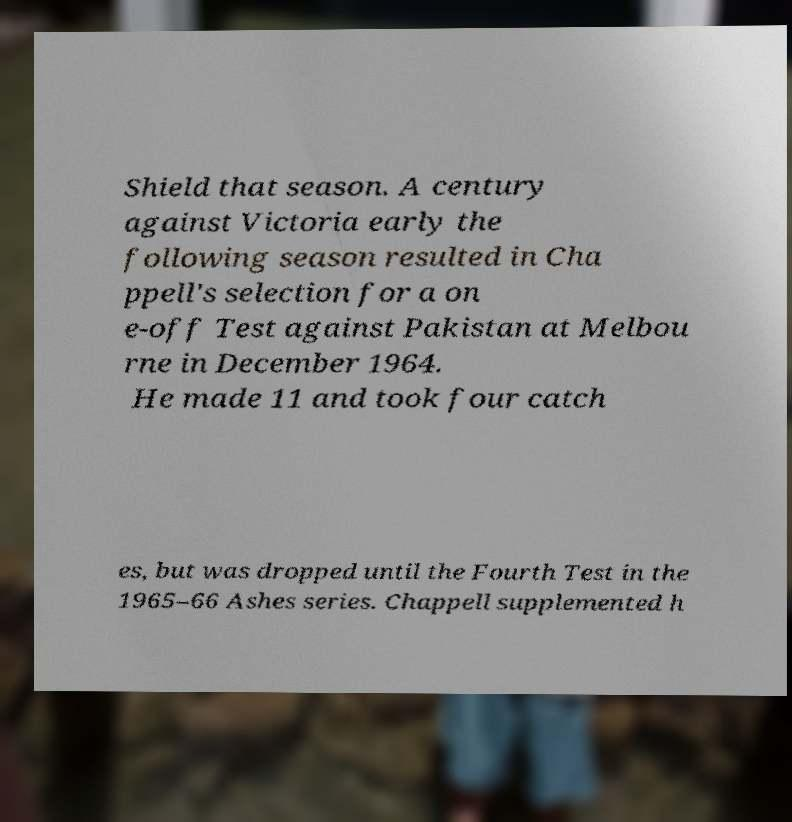Can you accurately transcribe the text from the provided image for me? Shield that season. A century against Victoria early the following season resulted in Cha ppell's selection for a on e-off Test against Pakistan at Melbou rne in December 1964. He made 11 and took four catch es, but was dropped until the Fourth Test in the 1965–66 Ashes series. Chappell supplemented h 